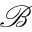<formula> <loc_0><loc_0><loc_500><loc_500>\mathcal { B }</formula> 